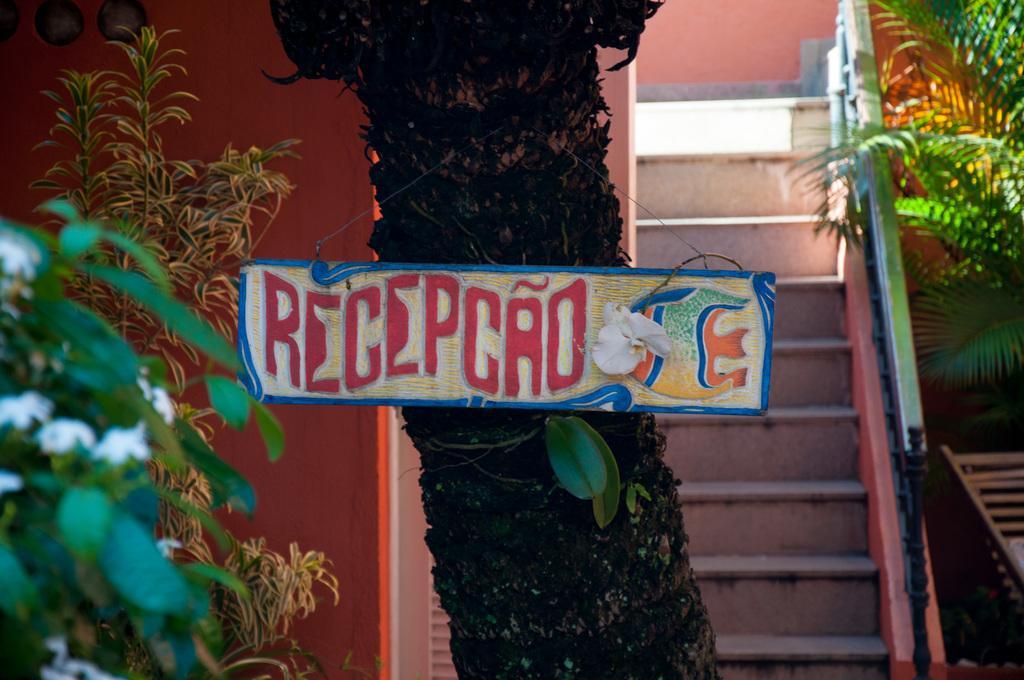Could you give a brief overview of what you see in this image? In this picture we can see a tree trunk with a name board. On the left and right side of the image, there are trees. Behind the tree trunk, there is a stair. In the bottom right corner of the image, there is a wooden object. 